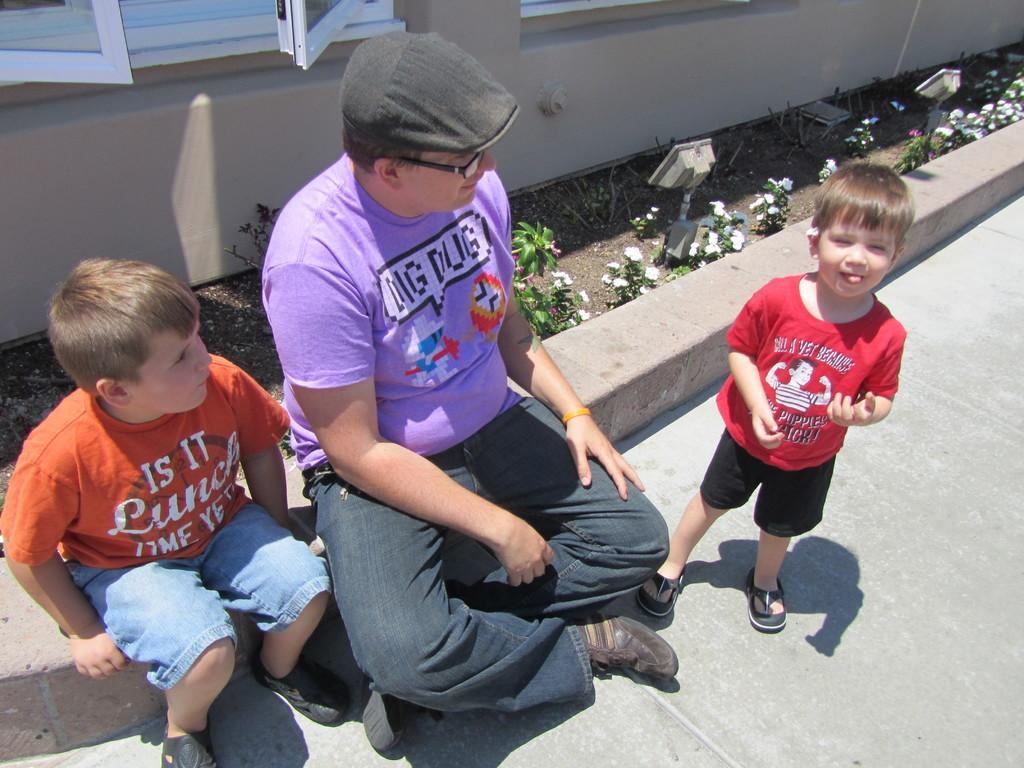Who is present in the image? There is a man, a boy sitting, and another boy standing in the image. What are the boys doing in the image? The boy sitting is in a relaxed position, while the boy standing is likely observing or interacting with the man. What can be seen in the background of the image? There is a window visible in the background of the image. Are there any plants in the image? Yes, there are plants visible in the image. What type of toothbrush is the man using in the image? There is no toothbrush present in the image; the man is not engaged in any activity that would involve a toothbrush. 